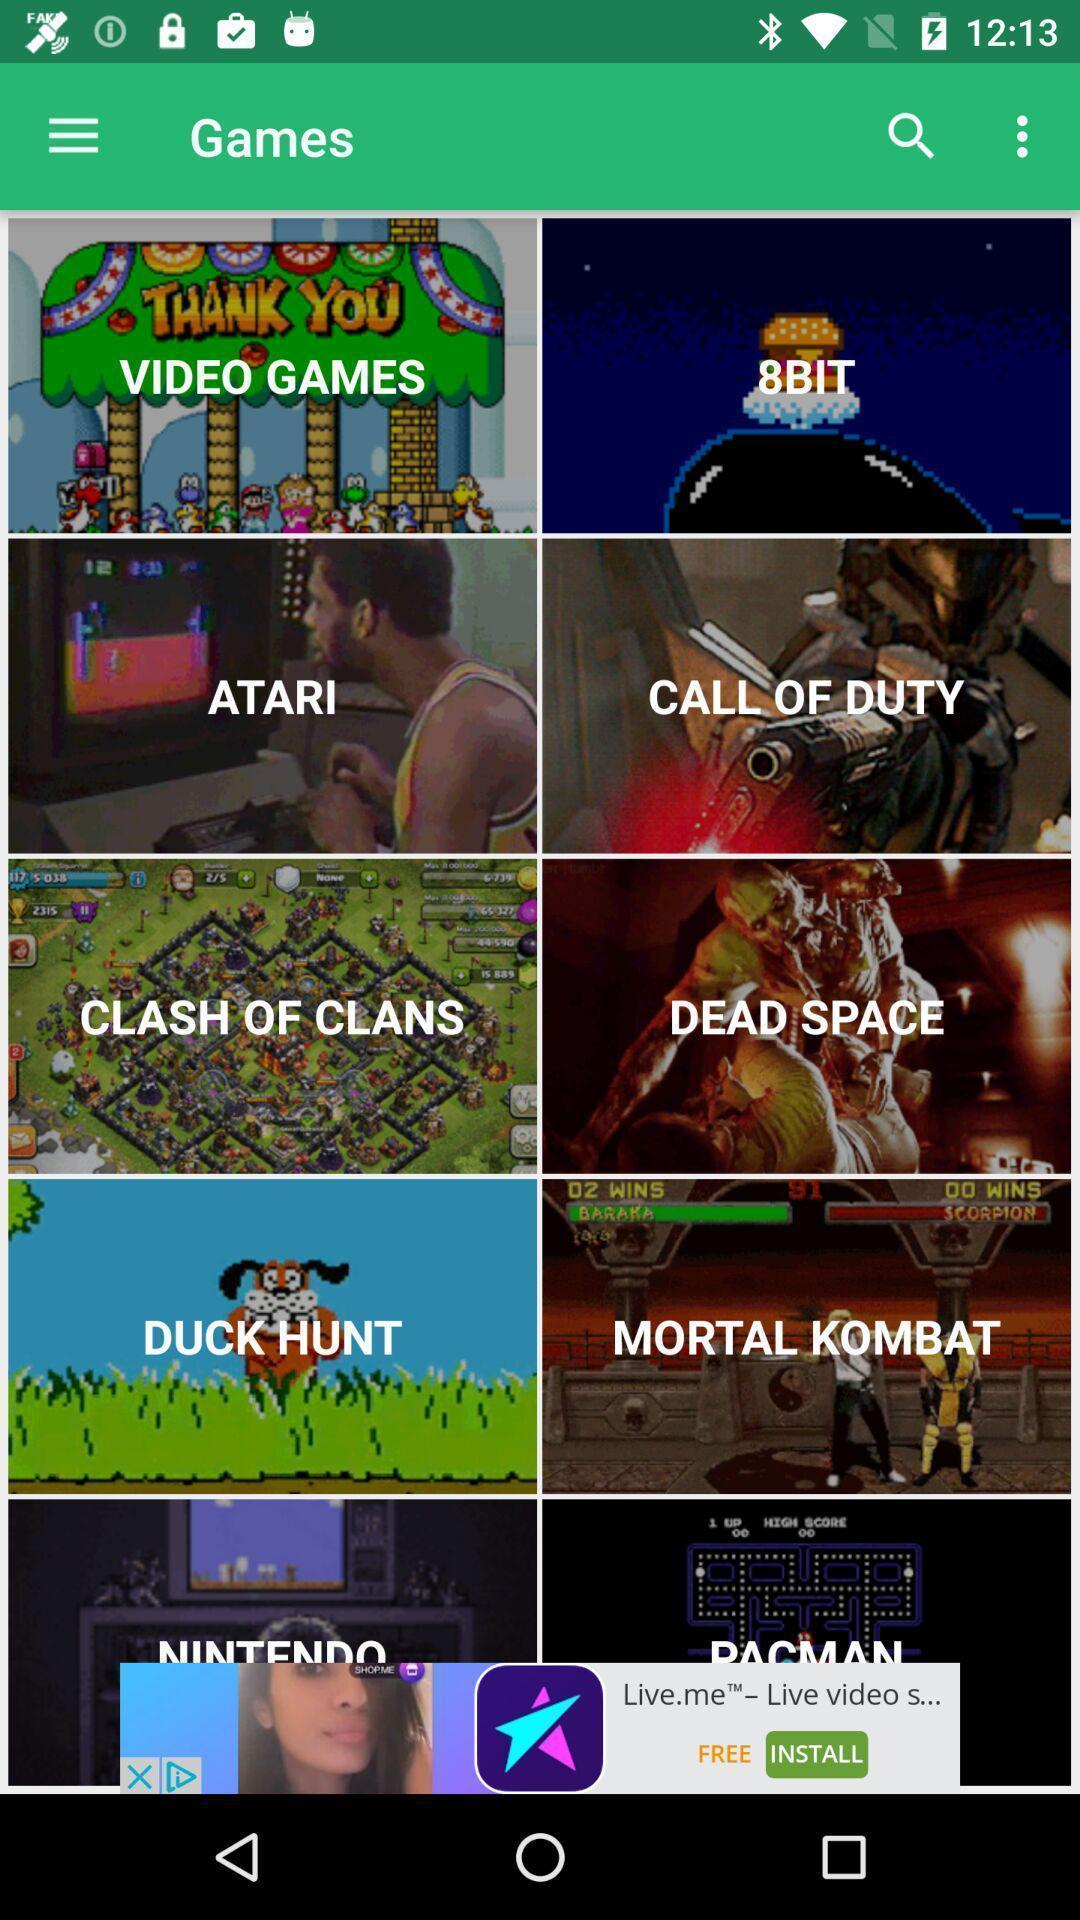Describe the visual elements of this screenshot. Page showing different games on an app. 